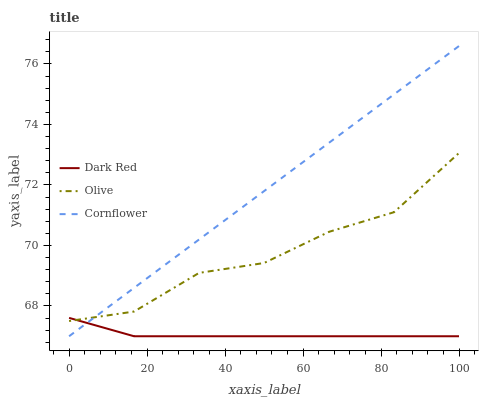Does Dark Red have the minimum area under the curve?
Answer yes or no. Yes. Does Cornflower have the minimum area under the curve?
Answer yes or no. No. Does Dark Red have the maximum area under the curve?
Answer yes or no. No. Is Dark Red the smoothest?
Answer yes or no. No. Is Dark Red the roughest?
Answer yes or no. No. Does Dark Red have the highest value?
Answer yes or no. No. 